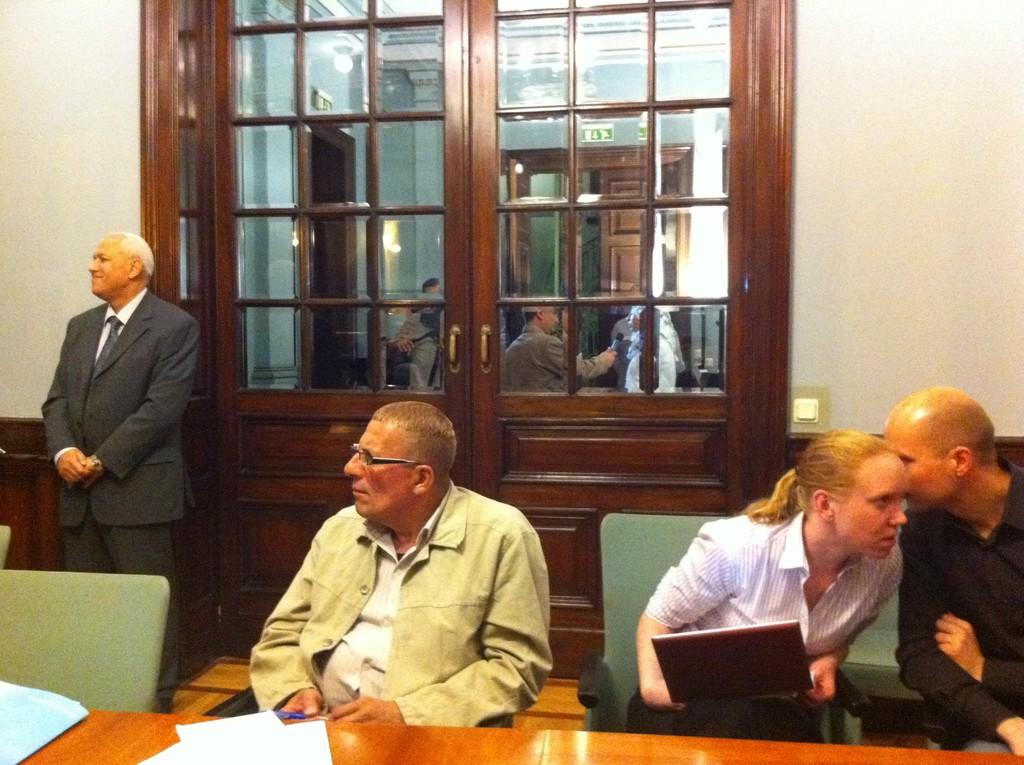How many people are sitting in chairs in the image? There are two men sitting in chairs in the image. Who is sitting between the two men? There is a girl sitting between the two men. What is the man at the door doing? A man is standing at a door in the image. Can you describe the scene outside the door? There are people outside the door in the image. What phase is the moon in during the fight scene in the image? There is no fight scene or moon present in the image. 